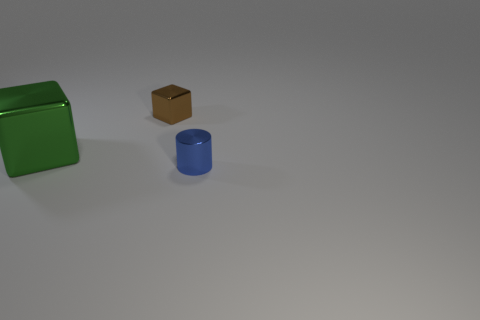How many other things are there of the same shape as the tiny blue metal thing?
Your answer should be compact. 0. Is there any other thing of the same color as the small metallic cylinder?
Keep it short and to the point. No. Do the tiny metallic cylinder and the shiny thing on the left side of the brown metal thing have the same color?
Your response must be concise. No. What number of other objects are there of the same size as the blue cylinder?
Offer a very short reply. 1. What number of cubes are either big cyan shiny things or shiny things?
Offer a terse response. 2. Do the thing that is behind the large metallic cube and the big green thing have the same shape?
Offer a terse response. Yes. Is the number of shiny objects that are on the right side of the large green metal block greater than the number of cylinders?
Your answer should be compact. Yes. The other metal thing that is the same size as the brown shiny thing is what color?
Offer a terse response. Blue. What number of objects are big objects that are to the left of the small metallic cylinder or tiny green balls?
Make the answer very short. 1. The small thing that is in front of the small metal thing that is behind the tiny blue metallic cylinder is made of what material?
Provide a succinct answer. Metal. 